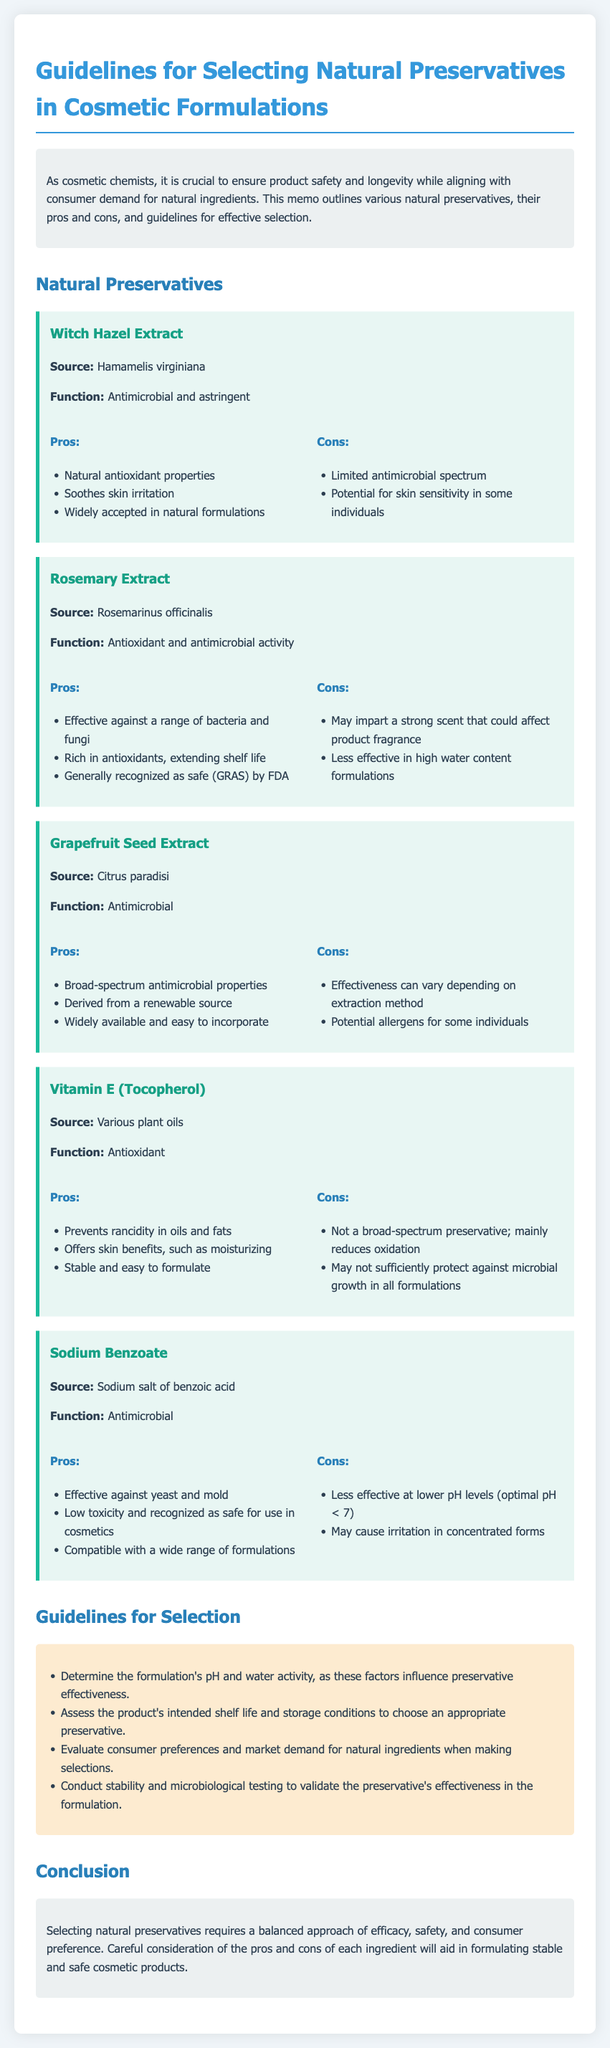What is the source of Witch Hazel Extract? The source of Witch Hazel Extract is mentioned as Hamamelis virginiana.
Answer: Hamamelis virginiana How many natural preservatives are discussed in the memo? The memo discusses a total of five natural preservatives.
Answer: Five What is a pro of using Rosemary Extract? One of the pros listed for Rosemary Extract is that it is effective against a range of bacteria and fungi.
Answer: Effective against a range of bacteria and fungi What must be determined to choose an appropriate preservative? The formulation's pH and water activity must be determined to choose an appropriate preservative.
Answer: Formulation's pH and water activity Which preservative is recognized as safe (GRAS) by the FDA? The preservative recognized as safe (GRAS) by the FDA is Rosemary Extract.
Answer: Rosemary Extract What is the main function of Vitamin E (Tocopherol)? The main function of Vitamin E (Tocopherol) is listed as an antioxidant.
Answer: Antioxidant What is a con of using Grapefruit Seed Extract? One con of using Grapefruit Seed Extract is that its effectiveness can vary depending on the extraction method.
Answer: Effectiveness can vary What guideline involves testing the preservative's effectiveness? Conducting stability and microbiological testing involves testing the preservative's effectiveness in the formulation.
Answer: Stability and microbiological testing 